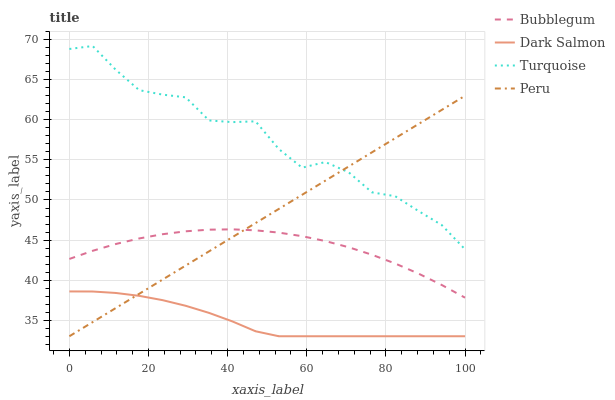Does Dark Salmon have the minimum area under the curve?
Answer yes or no. Yes. Does Turquoise have the maximum area under the curve?
Answer yes or no. Yes. Does Turquoise have the minimum area under the curve?
Answer yes or no. No. Does Dark Salmon have the maximum area under the curve?
Answer yes or no. No. Is Peru the smoothest?
Answer yes or no. Yes. Is Turquoise the roughest?
Answer yes or no. Yes. Is Dark Salmon the smoothest?
Answer yes or no. No. Is Dark Salmon the roughest?
Answer yes or no. No. Does Peru have the lowest value?
Answer yes or no. Yes. Does Turquoise have the lowest value?
Answer yes or no. No. Does Turquoise have the highest value?
Answer yes or no. Yes. Does Dark Salmon have the highest value?
Answer yes or no. No. Is Bubblegum less than Turquoise?
Answer yes or no. Yes. Is Turquoise greater than Dark Salmon?
Answer yes or no. Yes. Does Dark Salmon intersect Peru?
Answer yes or no. Yes. Is Dark Salmon less than Peru?
Answer yes or no. No. Is Dark Salmon greater than Peru?
Answer yes or no. No. Does Bubblegum intersect Turquoise?
Answer yes or no. No. 